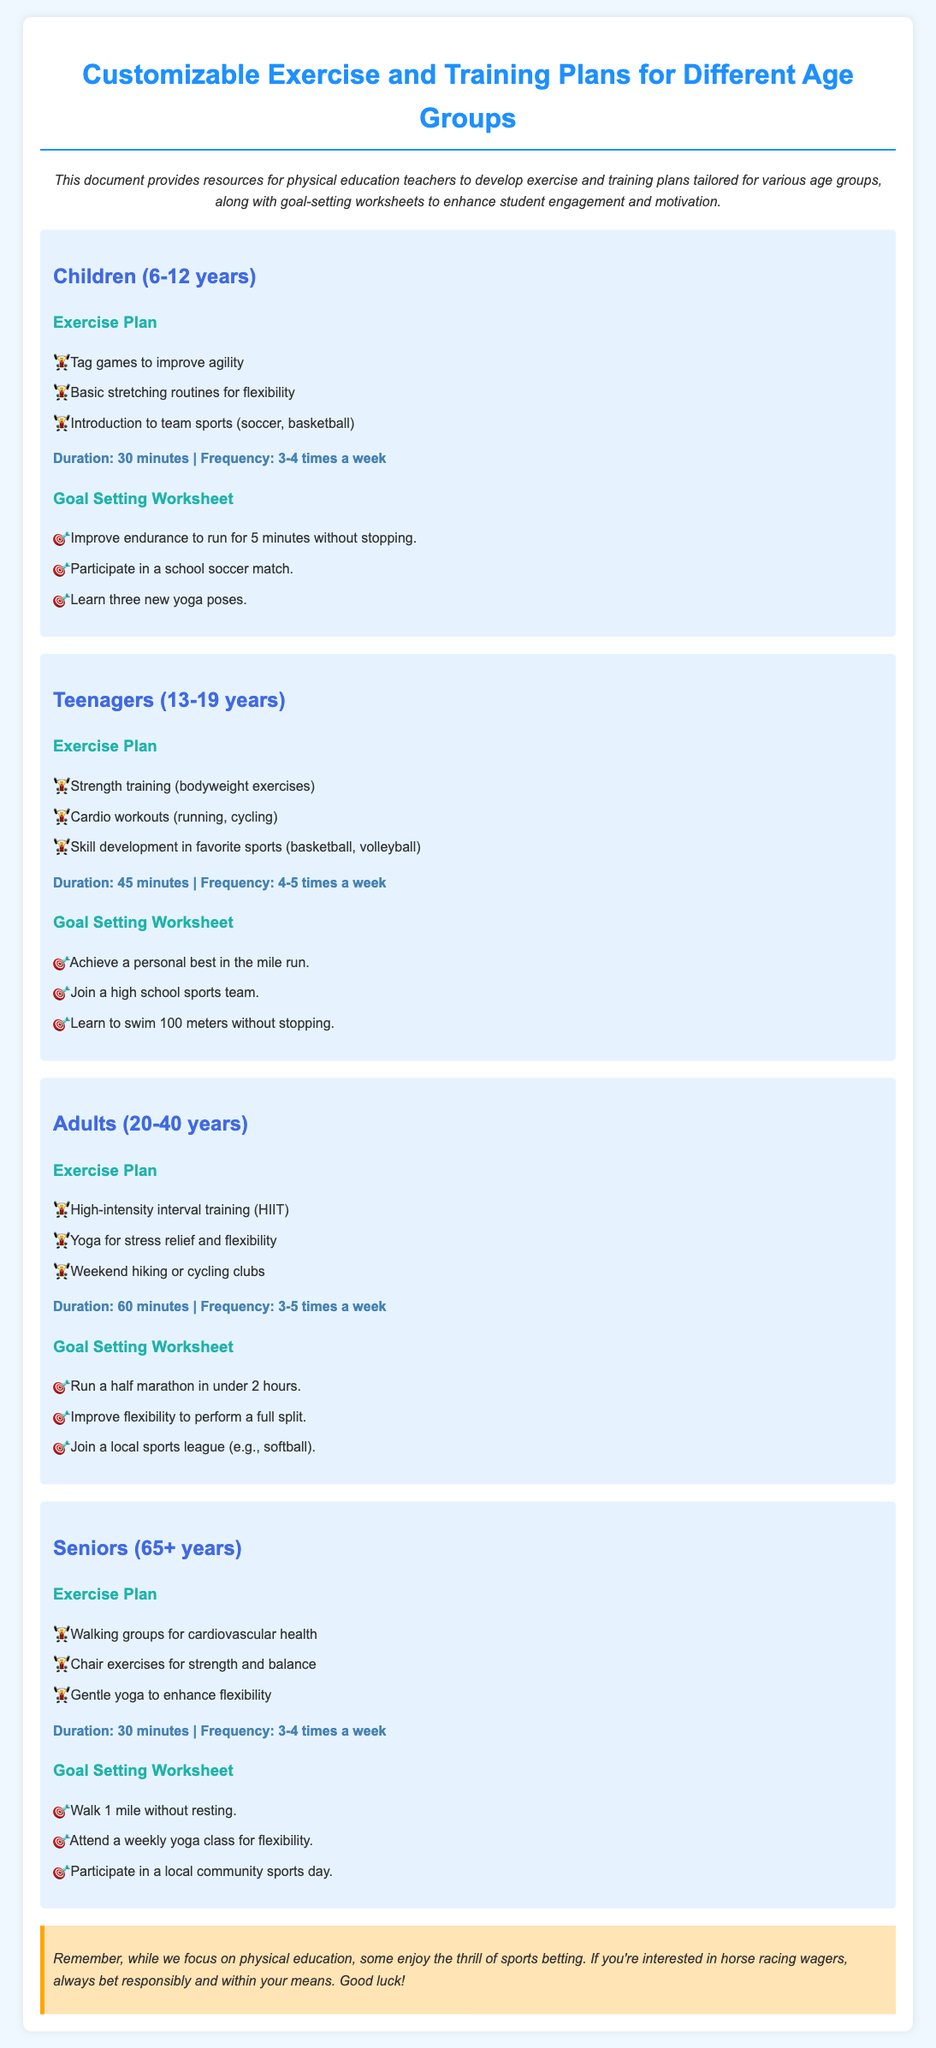What is the exercise duration for children? The document states the exercise plan duration for children is 30 minutes.
Answer: 30 minutes How many times a week should adults exercise? The document specifies that adults should exercise 3-5 times a week.
Answer: 3-5 times a week What is one goal for seniors? The goal-setting worksheet for seniors includes the goal to walk 1 mile without resting.
Answer: Walk 1 mile without resting What type of training is recommended for teenagers? One of the recommended exercise plans for teenagers is strength training (bodyweight exercises).
Answer: Strength training (bodyweight exercises) What is the frequency of exercise for children? The document mentions the frequency of exercise for children is 3-4 times a week.
Answer: 3-4 times a week How long is the exercise duration for adults? The document states that the exercise duration for adults is 60 minutes.
Answer: 60 minutes Which age group has chair exercises in their plan? The exercise plan for seniors includes chair exercises for strength and balance.
Answer: Seniors What is one goal for teenagers? One of the goals listed for teenagers is to achieve a personal best in the mile run.
Answer: Achieve a personal best in the mile run What type of yoga is suggested for adults? Adults are recommended to practice yoga for stress relief and flexibility.
Answer: Yoga for stress relief and flexibility 